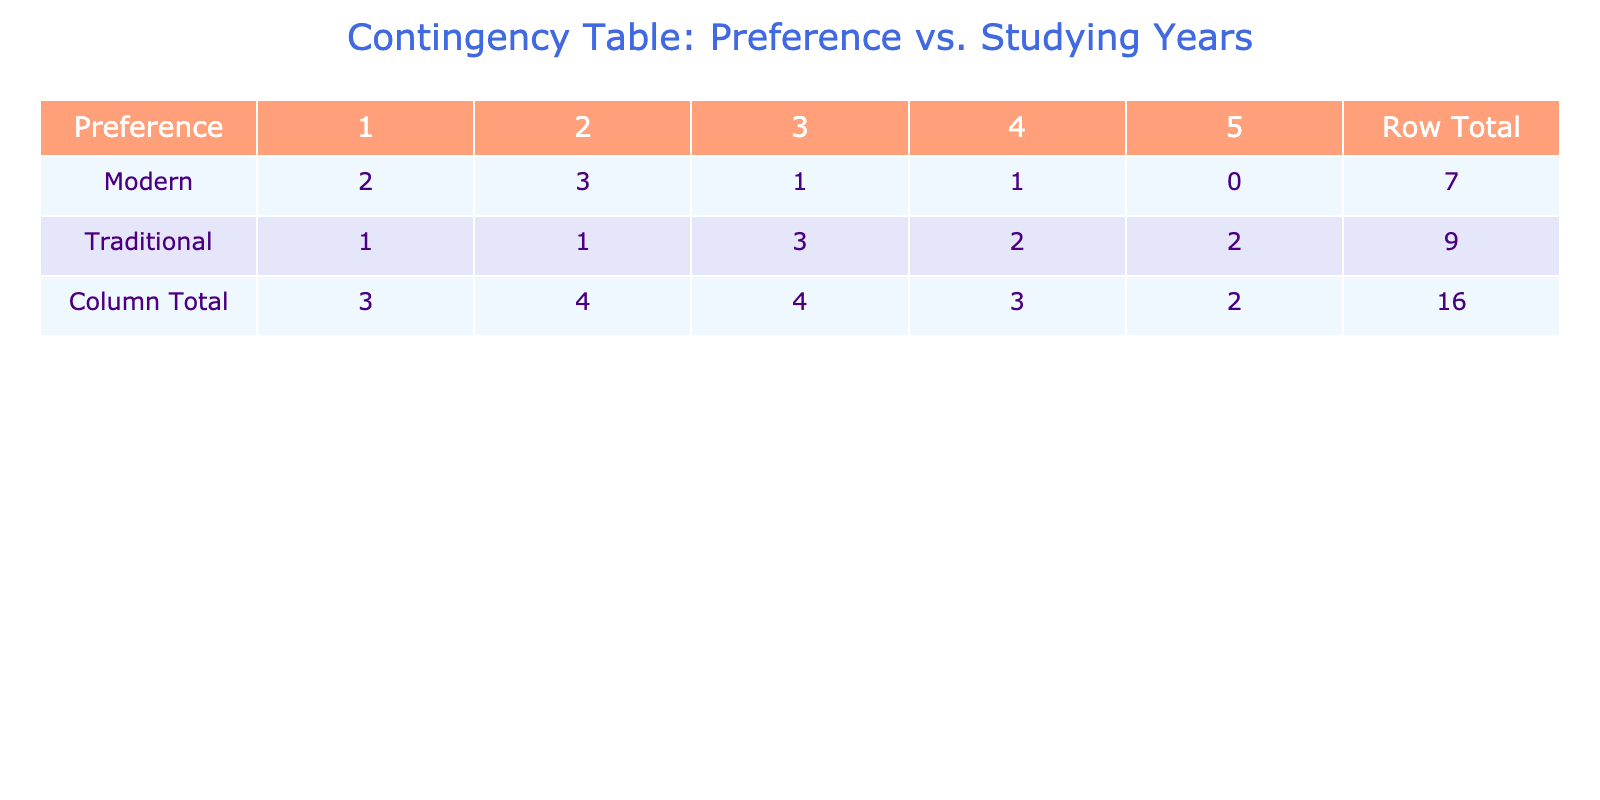What is the total number of musicians preferring traditional music? There are a total of 7 musicians listed under the preference for traditional music: Li Wei, Wang Jie, Liu Feng, Zhou Jun, Yuan Hui, Huang Li, and Kong Yan.
Answer: 7 How many musicians studied for 5 years and preferred modern music? In the table, there are no musicians listed who have studied for 5 years and prefer modern music.
Answer: 0 What percentage of musicians from Guangzhou prefer traditional music? There are 3 musicians from Guangzhou, 2 of whom prefer traditional music (Wang Jie and Yuan Hui). Therefore, the percentage is (2/3) * 100 = 66.67%.
Answer: 66.67% Is there a musician who studied exactly 3 years and prefers modern music? Looking through the table, the only musicians who studied for exactly 3 years are Li Wei, Zhou Jun, and Qiu Lian. Among these, Qiu Lian prefers modern music. Thus, there is one such musician.
Answer: Yes What is the average studying years for musicians who prefer traditional music? The total studying years for traditional music are 3 (Li Wei) + 4 (Wang Jie) + 5 (Liu Feng) + 3 (Zhou Jun) + 2 (Yuan Hui) + 5 (Huang Li) + 4 (Kong Yan) = 26. With 7 musicians in total, the average is 26 / 7 = approximately 3.71 years.
Answer: 3.71 How many musicians are there from Beijing, and what percentage prefer modern music? There are 2 musicians from Beijing: Li Wei (traditional) and Li Na (modern). Out of these, 1 prefers modern music, giving a percentage of (1/2) * 100 = 50%.
Answer: 50% Does any musician from Nanjing prefer modern music? The musicians from Nanjing are Liu Feng (traditional) and Gao Wei (traditional), and neither of them prefers modern music.
Answer: No What is the total number of musicians who prefer modern music with more than 3 studying years? The musicians who prefer modern music and have studied more than 3 years are He Yu (4 years), Chen Ming (2 years), and Qiu Lian (3 years). The only one who fits the criteria is He Yu. Thus, the total is 1.
Answer: 1 